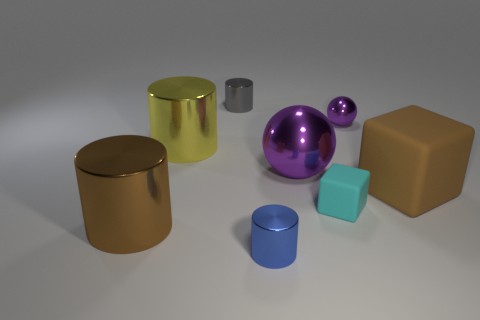How many purple balls must be subtracted to get 1 purple balls? 1 Subtract all blue cylinders. How many cylinders are left? 3 Add 2 brown cylinders. How many objects exist? 10 Subtract all cubes. How many objects are left? 6 Add 1 small metallic cylinders. How many small metallic cylinders are left? 3 Add 1 gray metallic spheres. How many gray metallic spheres exist? 1 Subtract 0 yellow balls. How many objects are left? 8 Subtract all cyan cylinders. Subtract all red balls. How many cylinders are left? 4 Subtract all small balls. Subtract all big brown blocks. How many objects are left? 6 